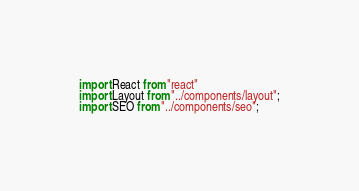Convert code to text. <code><loc_0><loc_0><loc_500><loc_500><_JavaScript_>import React from "react"
import Layout from "../components/layout";
import SEO from "../components/seo";</code> 